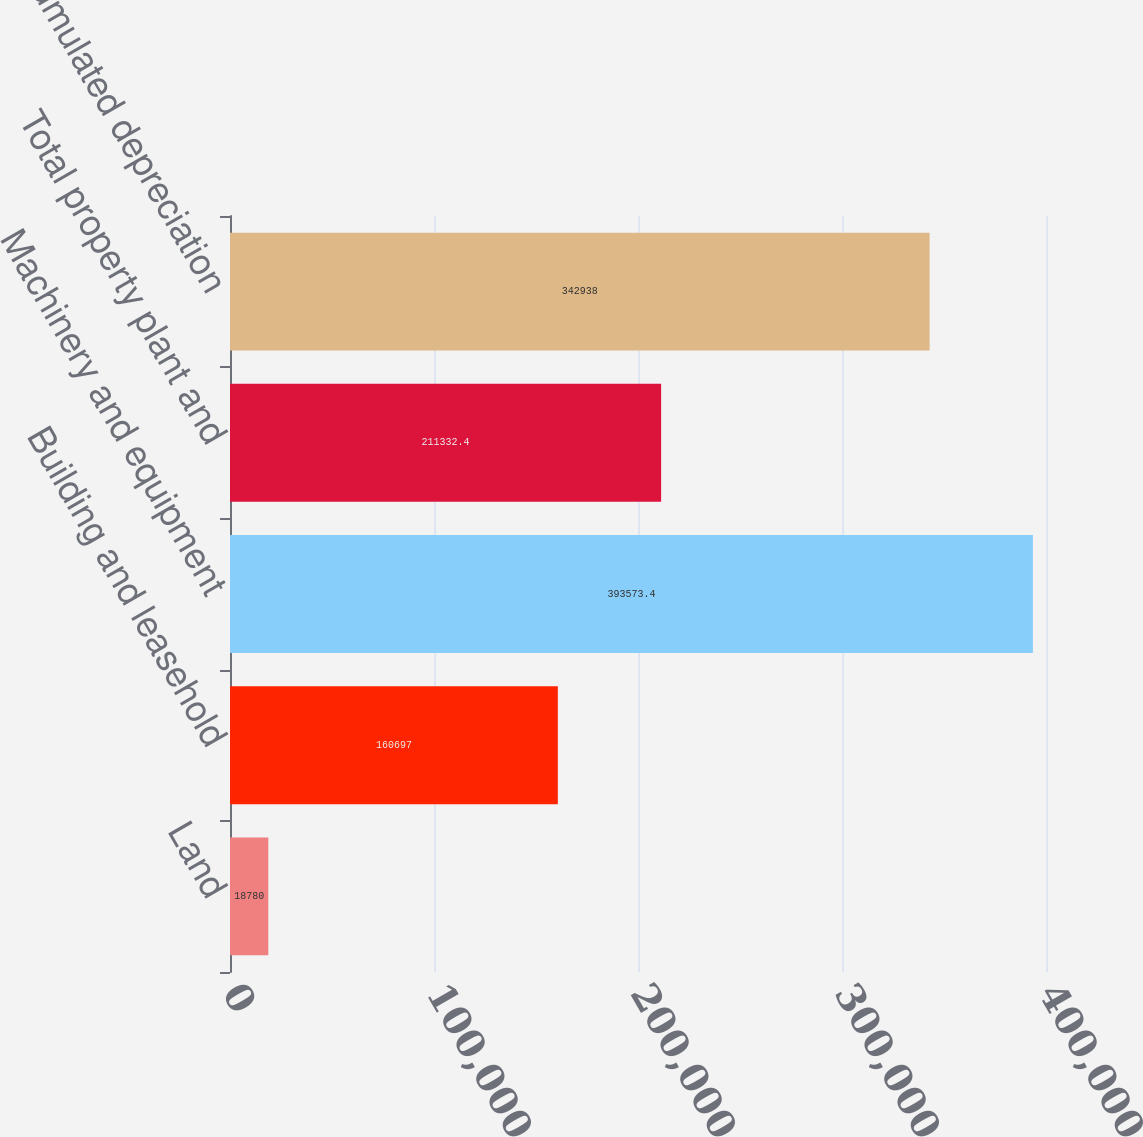Convert chart. <chart><loc_0><loc_0><loc_500><loc_500><bar_chart><fcel>Land<fcel>Building and leasehold<fcel>Machinery and equipment<fcel>Total property plant and<fcel>Accumulated depreciation<nl><fcel>18780<fcel>160697<fcel>393573<fcel>211332<fcel>342938<nl></chart> 